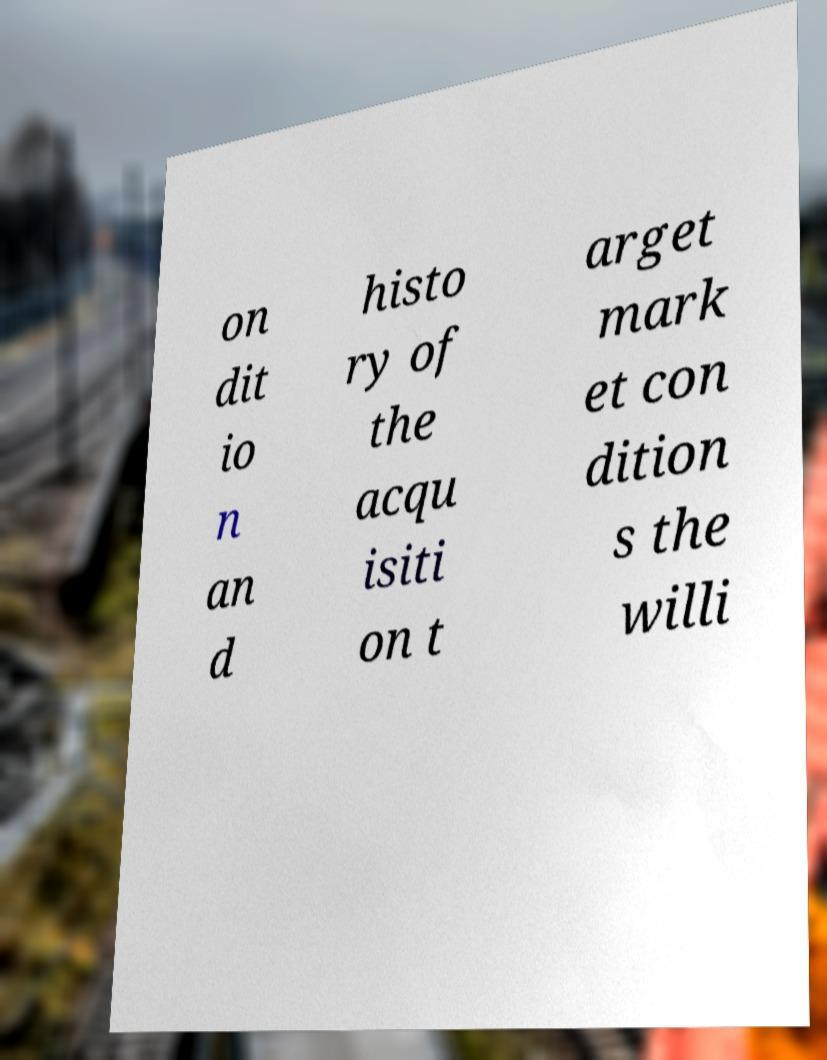For documentation purposes, I need the text within this image transcribed. Could you provide that? on dit io n an d histo ry of the acqu isiti on t arget mark et con dition s the willi 